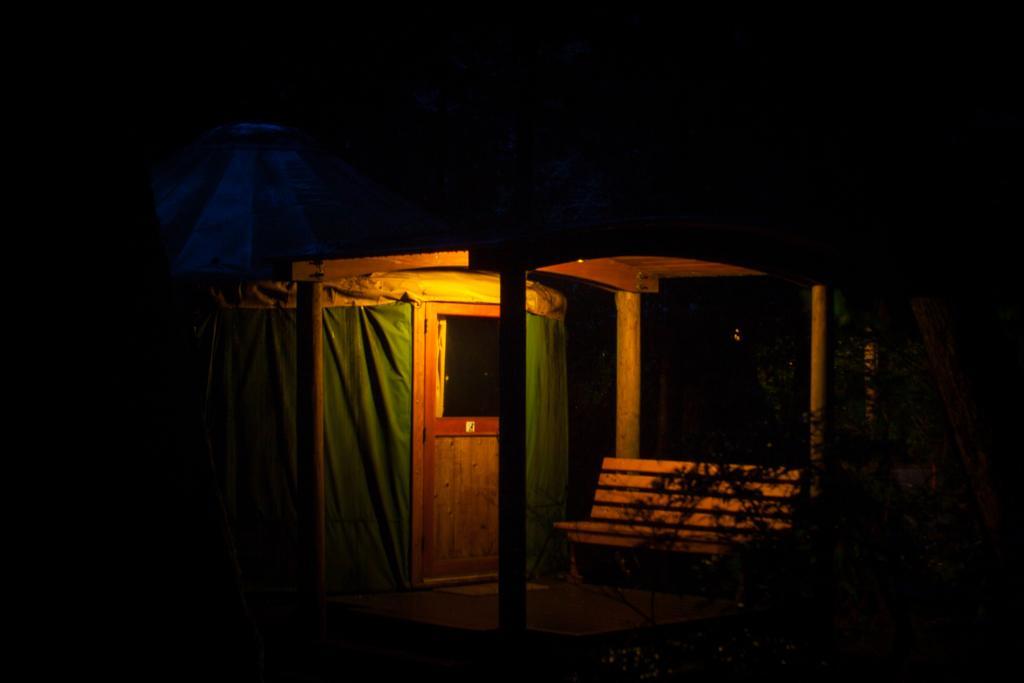How would you summarize this image in a sentence or two? In this picture we can observe a brown color door and a green color cloth. There is a bench. We can observe some plants and yellow color light. The background is completely dark. 